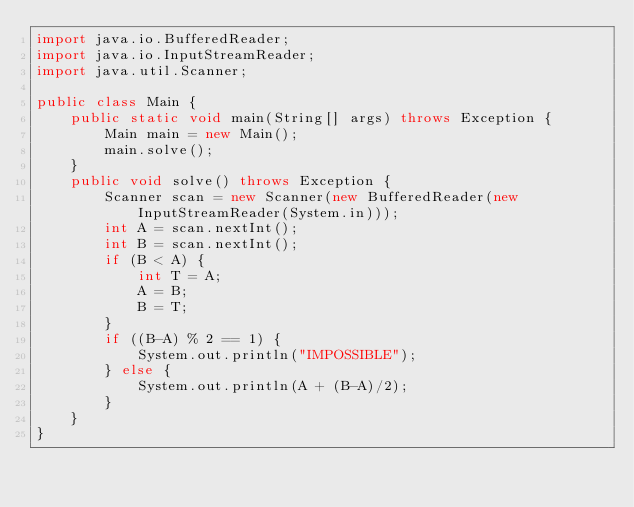<code> <loc_0><loc_0><loc_500><loc_500><_Java_>import java.io.BufferedReader;
import java.io.InputStreamReader;
import java.util.Scanner;

public class Main {
    public static void main(String[] args) throws Exception {
        Main main = new Main();
        main.solve();
    }
    public void solve() throws Exception {
        Scanner scan = new Scanner(new BufferedReader(new InputStreamReader(System.in)));
        int A = scan.nextInt();
        int B = scan.nextInt();
        if (B < A) {
            int T = A;
            A = B;
            B = T;
        }
        if ((B-A) % 2 == 1) {
            System.out.println("IMPOSSIBLE");
        } else {
            System.out.println(A + (B-A)/2);
        }
    }
}
</code> 